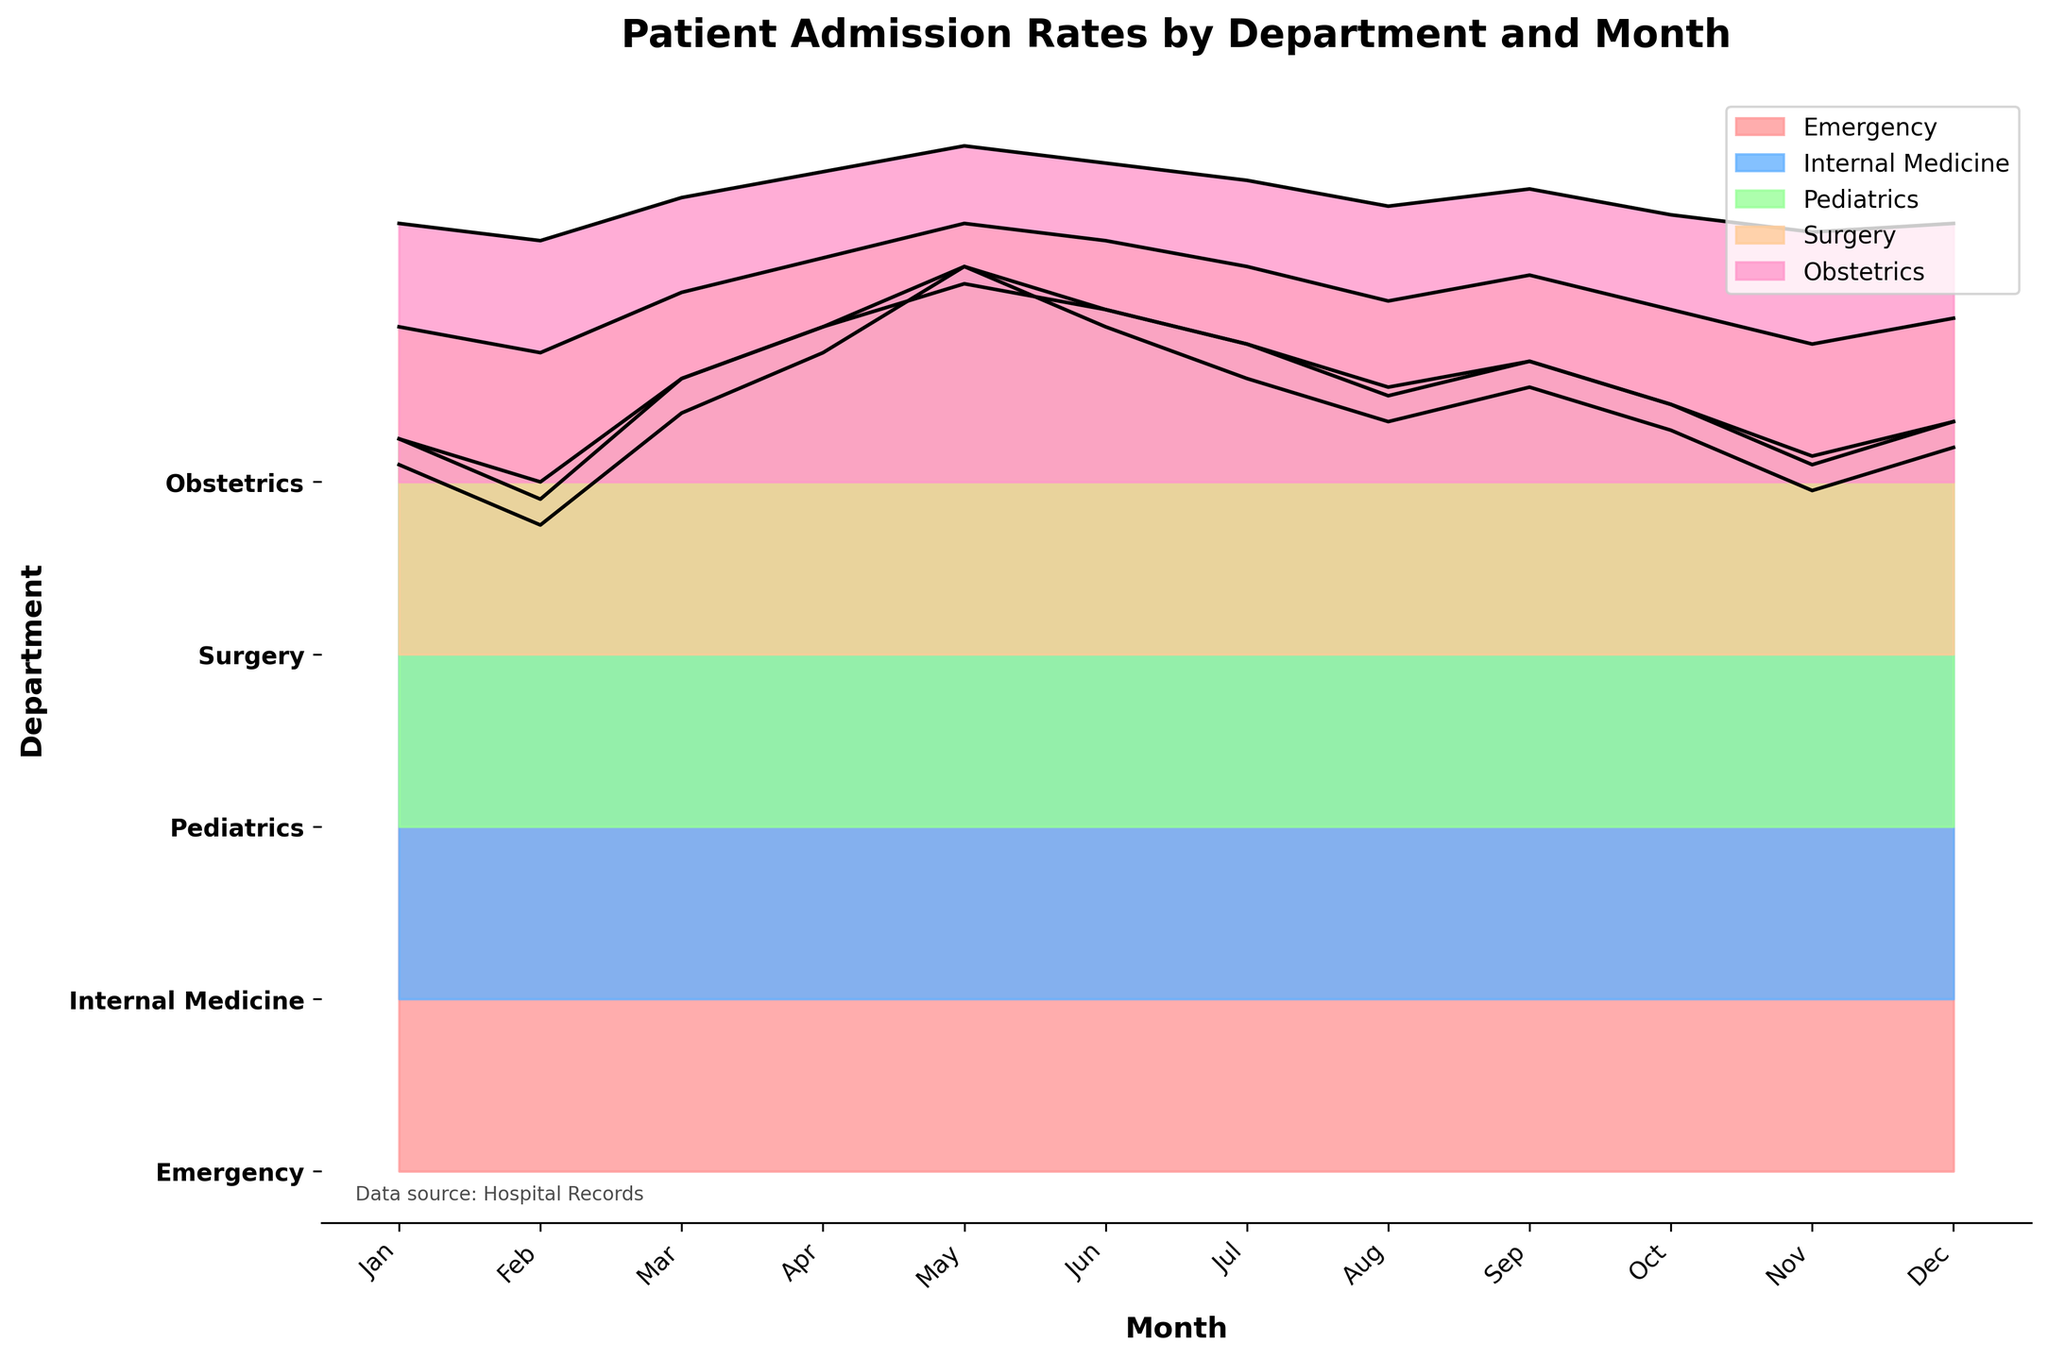Which department has the highest peak in patient admissions? The highest peak can be observed by looking at the tallest ridgeline. The Emergency department in May has the highest peak with 105 admissions.
Answer: Emergency During which month did the Internal Medicine department see the highest admissions? Look at the ridgeline corresponding to Internal Medicine and identify the month where the line reaches its highest point. The highest admissions of 85 are in May.
Answer: May How do the admission rates in Pediatrics compare between the months of May and October? For the Pediatrics department, note the values of admission in May and October from the ridgeline. There were 63 admissions in May and 49 in October.
Answer: May has more admissions than October Which department had the lowest average monthly patient admissions? Calculate the average admissions for each department. For example, Obstetrics averages 31.67, which is lower than any other department.
Answer: Obstetrics In which month did the Surgery department record its lowest admissions? Examine the Surgery department's ridgeline and find the lowest point. The lowest admissions of 35 are in February.
Answer: February Which department has the most consistent (least variation) monthly admissions throughout the year? Look at the variation in the ridgelines. Obstetrics shows the least variation in admissions compared to the other departments.
Answer: Obstetrics Which month experienced the highest collective patient admissions across all departments? Sum the admissions for each month across all departments, and compare. May has the highest collective total.
Answer: May If you combine the admissions for June across all departments, what is the total? Sum the admissions for each department in June: 98 (Emergency) + 80 (Internal Medicine) + 60 (Pediatrics) + 48 (Surgery) + 37 (Obstetrics) = 323
Answer: 323 Which department shows a significant drop in patient admissions from January to February? Compare January and February admissions for each department. The Pediatrics department drops from 45 to 40.
Answer: Pediatrics How does the peak admission in November for Emergency compare to that of December? Examine the Emergency ridgeline to compare admissions in November and December. The peak is 79 in November and 84 in December. December is slightly higher.
Answer: December is higher 